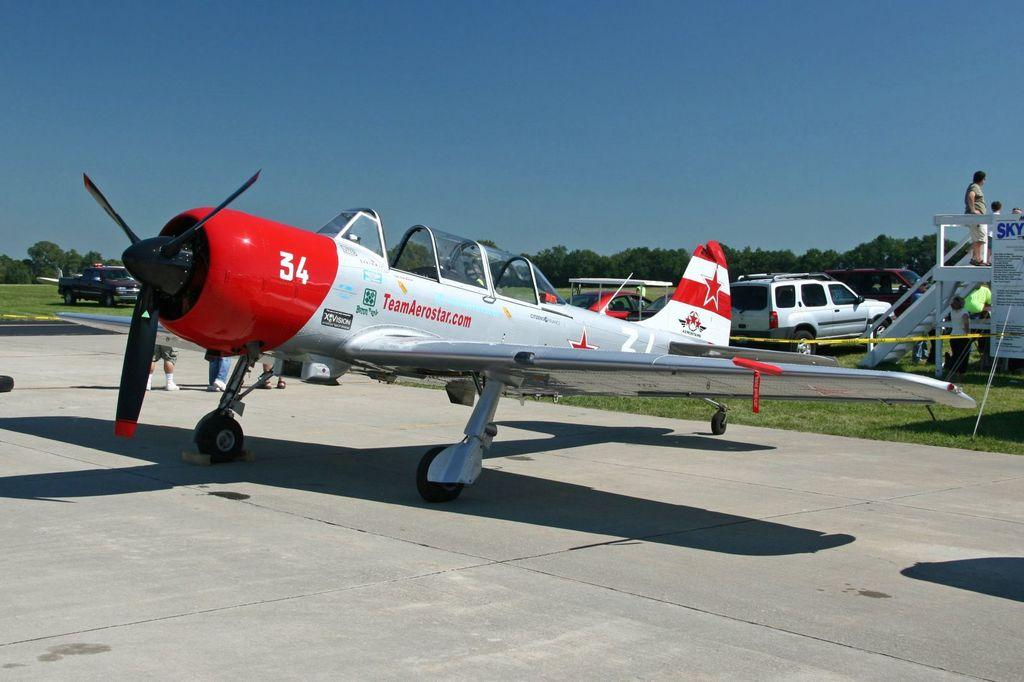Provide a one-sentence caption for the provided image. A number 34 is on the front of a red and white airplane. 